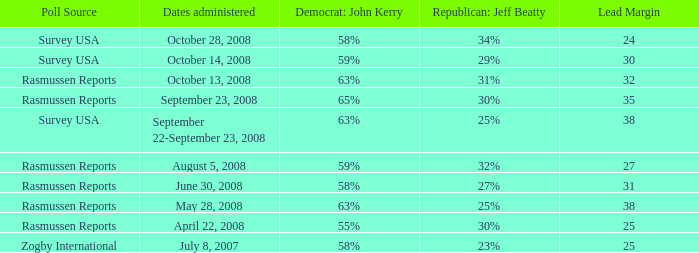Would you be able to parse every entry in this table? {'header': ['Poll Source', 'Dates administered', 'Democrat: John Kerry', 'Republican: Jeff Beatty', 'Lead Margin'], 'rows': [['Survey USA', 'October 28, 2008', '58%', '34%', '24'], ['Survey USA', 'October 14, 2008', '59%', '29%', '30'], ['Rasmussen Reports', 'October 13, 2008', '63%', '31%', '32'], ['Rasmussen Reports', 'September 23, 2008', '65%', '30%', '35'], ['Survey USA', 'September 22-September 23, 2008', '63%', '25%', '38'], ['Rasmussen Reports', 'August 5, 2008', '59%', '32%', '27'], ['Rasmussen Reports', 'June 30, 2008', '58%', '27%', '31'], ['Rasmussen Reports', 'May 28, 2008', '63%', '25%', '38'], ['Rasmussen Reports', 'April 22, 2008', '55%', '30%', '25'], ['Zogby International', 'July 8, 2007', '58%', '23%', '25']]} Who is the poll source that has Republican: Jeff Beatty behind at 27%? Rasmussen Reports. 